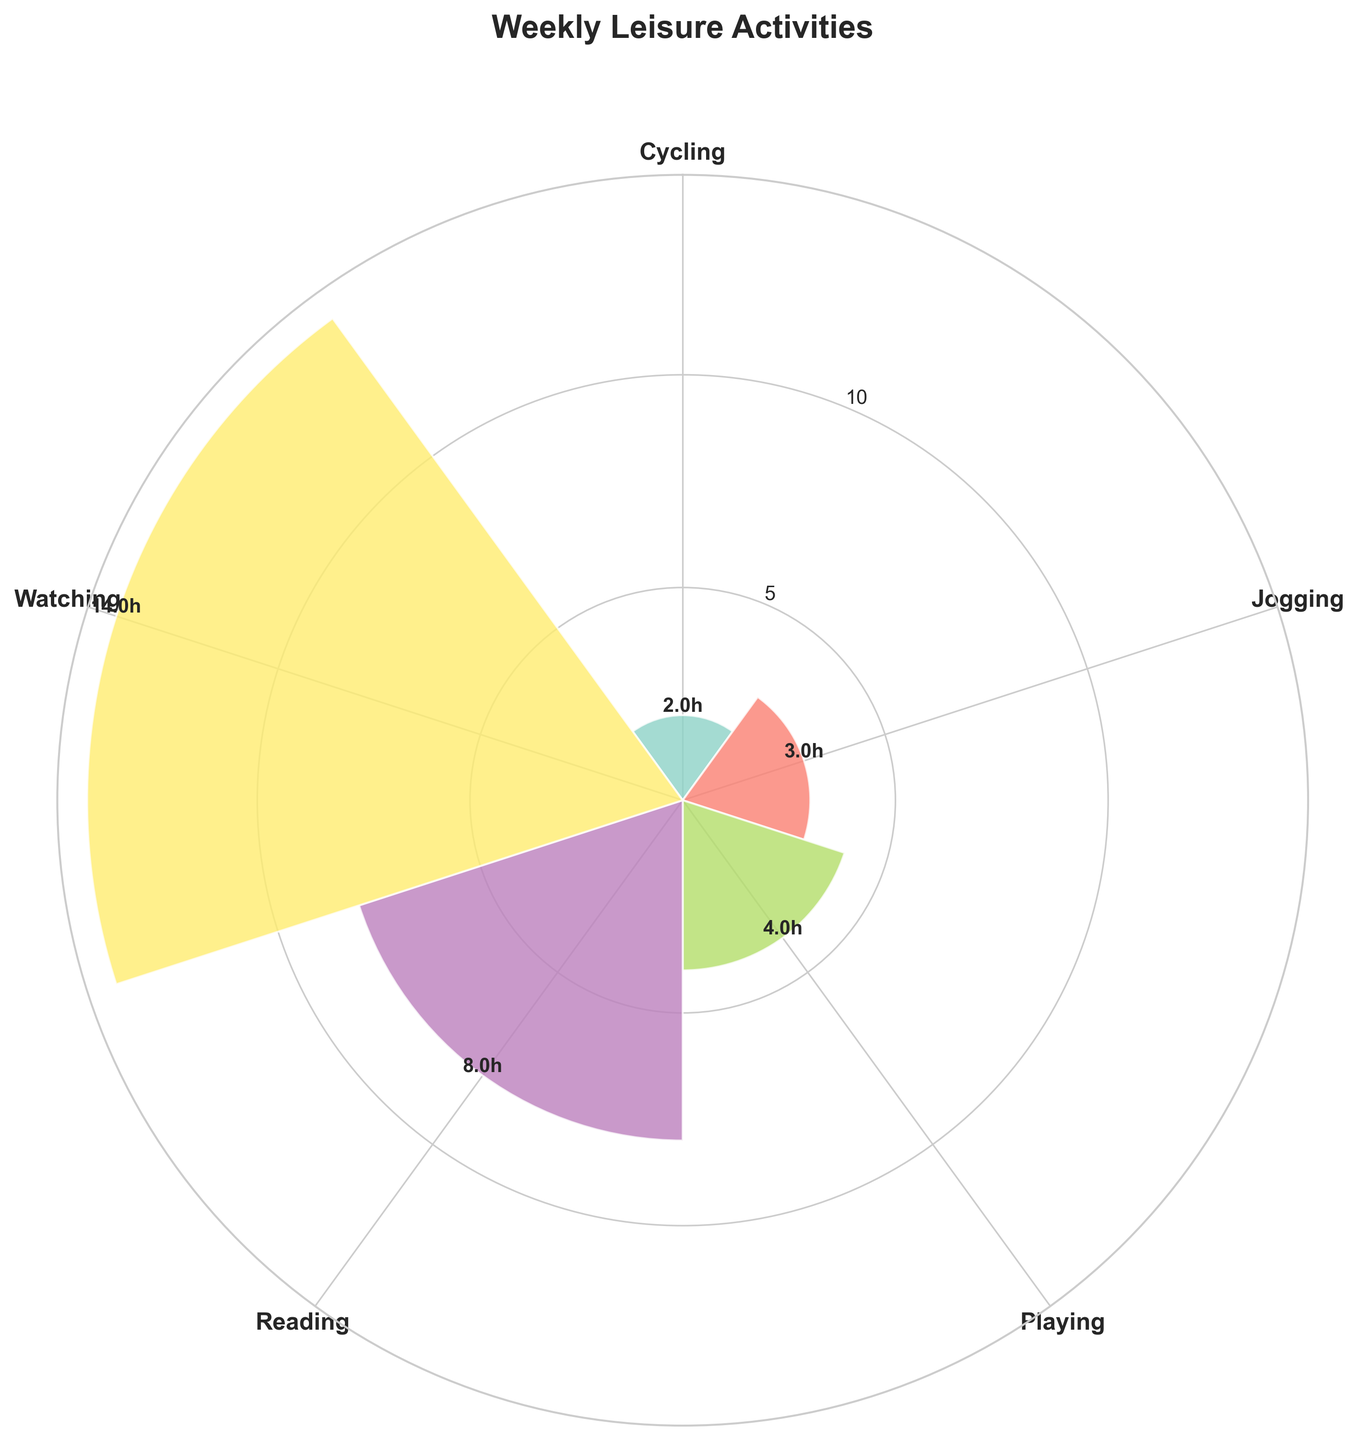What is the title of the figure? The title is usually displayed at the top of the figure. In this case, the title "Weekly Leisure Activities" is written at the top.
Answer: Weekly Leisure Activities Which activity has the largest number of hours per week? To determine this, look at the bars and compare their lengths. The longest bar represents the activity with the most hours per week.
Answer: Watching TV Series What is the total number of hours spent on reading activities per week? Add the hours for "Reading Novels" and "Reading Newspapers." "Reading Novels" is 5 hours, and "Reading Newspapers" is 3 hours. 5 + 3 = 8 hours.
Answer: 8 How many activities fall under the category "Sports"? The categories include "Playing Tennis," "Jogging," and "Cycling." Count these to get the number of activities.
Answer: 3 What is the average number of hours spent on watching activities per week? Sum the hours for "Watching TV Series" and "Watching Sports" and divide by 2. (8 + 6) / 2 = 7 hours.
Answer: 7 Which activity has the smallest number of hours per week? To find this, identify the shortest bar on the figure. The smallest bar corresponds to 2 hours per week.
Answer: Cycling Between Reading and Watching activities, which category has more hours in a week? Sum the hours for Reading (5 + 3 = 8) and Watching (8 + 6 = 14) to compare.
Answer: Watching What color represents the "Playing Tennis" activity? Identify the bar labelled "Playing" and note its color. It's part of the "Playing Tennis" group.
Answer: (The specific color may vary; this can be verified visually) How many hours are spent on playing sports per week in total? Add the hours for "Playing Tennis," "Jogging," and "Cycling." 4 + 3 + 2 = 9 hours.
Answer: 9 What is the difference in hours between "Watching TV Series" and "Playing Tennis"? Subtract the hours for "Playing Tennis" from "Watching TV Series." 8 - 4 = 4 hours difference.
Answer: 4 